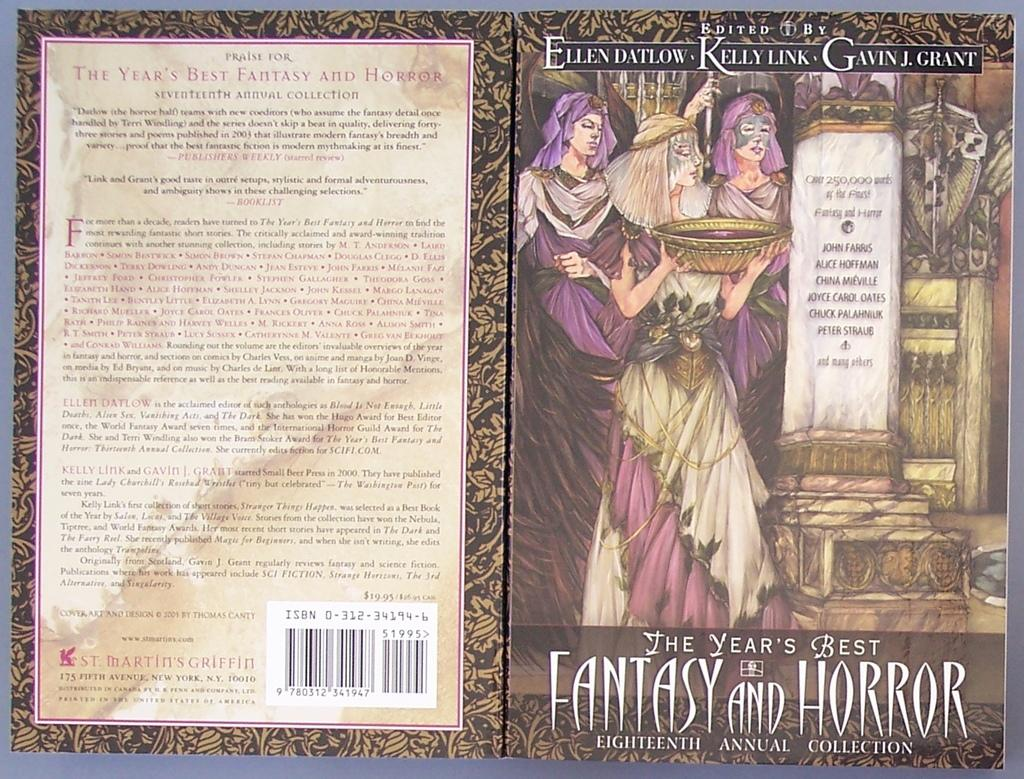<image>
Share a concise interpretation of the image provided. A collection of 'the year's best fantasty and horror' 